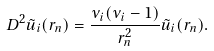<formula> <loc_0><loc_0><loc_500><loc_500>D ^ { 2 } \tilde { u } _ { i } ( r _ { n } ) = \frac { \nu _ { i } ( \nu _ { i } - 1 ) } { r _ { n } ^ { 2 } } \tilde { u } _ { i } ( r _ { n } ) .</formula> 